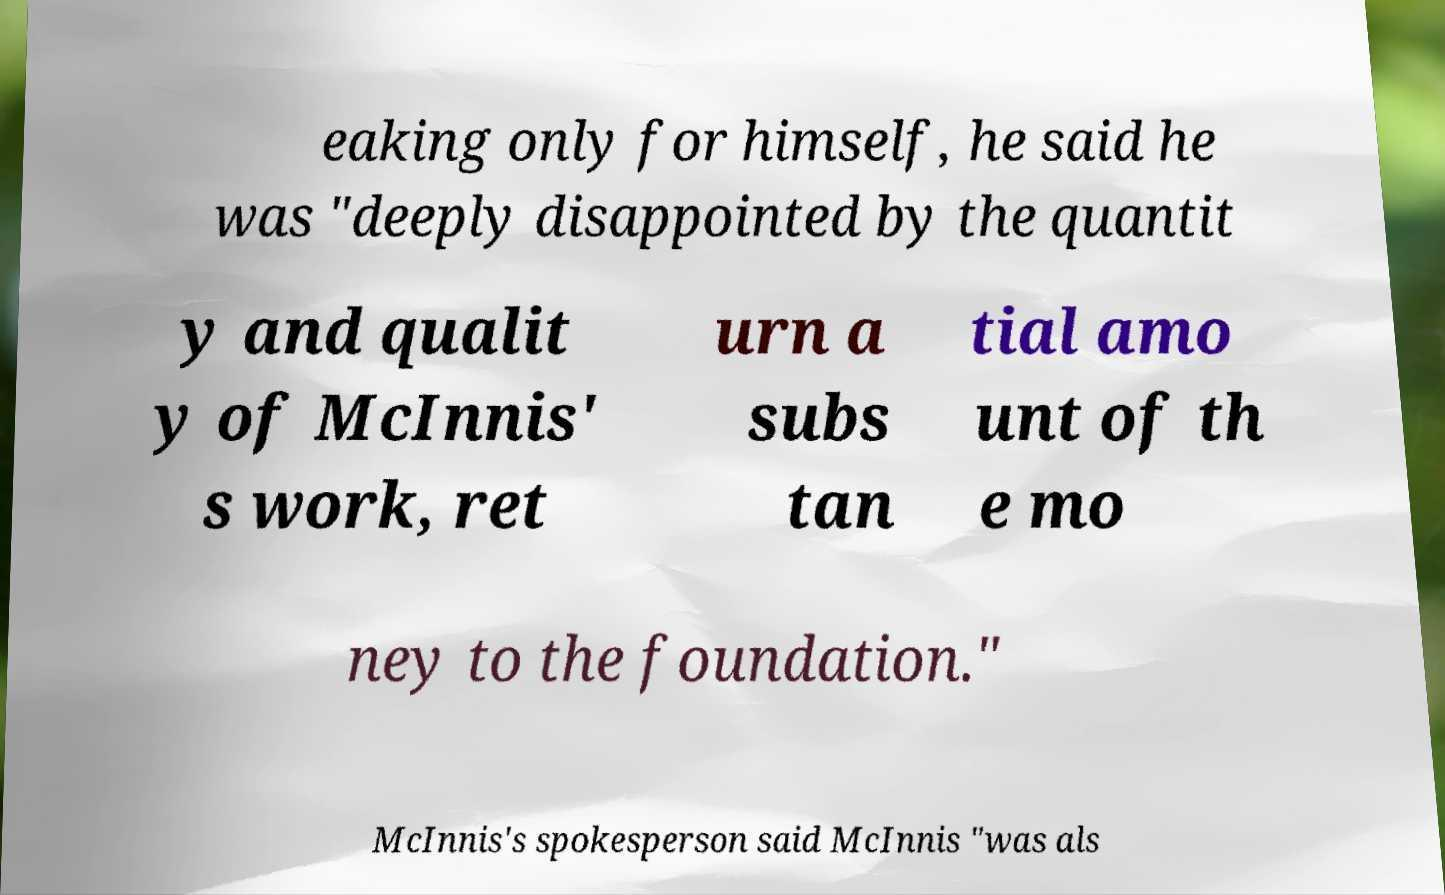Could you assist in decoding the text presented in this image and type it out clearly? eaking only for himself, he said he was "deeply disappointed by the quantit y and qualit y of McInnis' s work, ret urn a subs tan tial amo unt of th e mo ney to the foundation." McInnis's spokesperson said McInnis "was als 